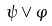<formula> <loc_0><loc_0><loc_500><loc_500>\psi \vee \varphi</formula> 